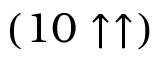Convert formula to latex. <formula><loc_0><loc_0><loc_500><loc_500>( 1 0 \uparrow \uparrow )</formula> 